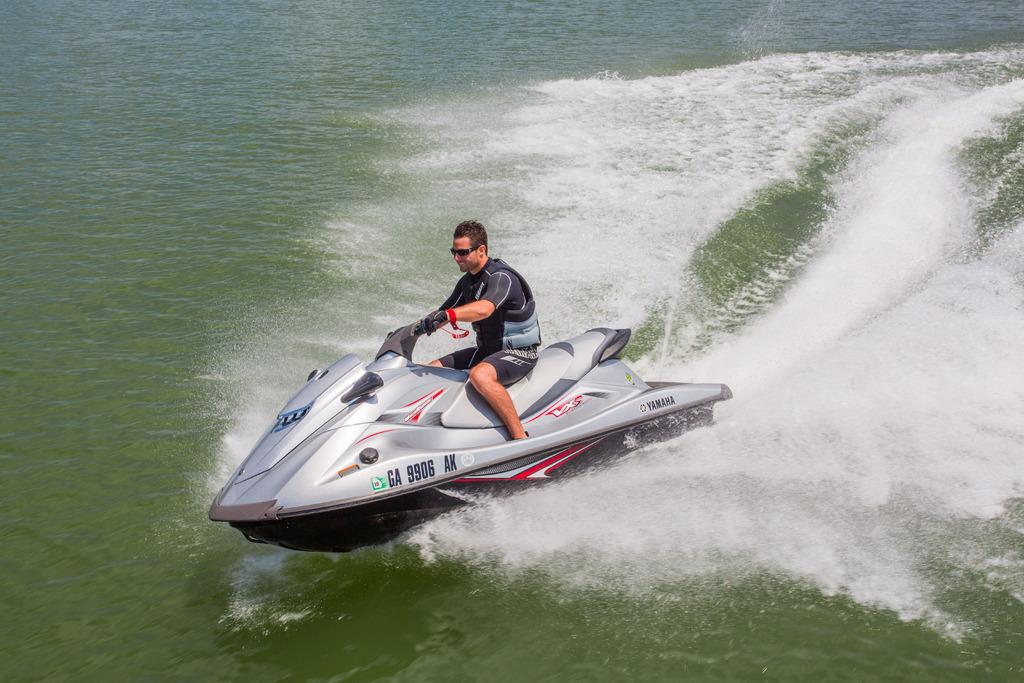Who is present in the image? There is a man in the image. What is the man doing in the image? The man is on a speedboat in the image. What type of environment is visible in the image? There is water visible in the image. What type of medical advice is the doctor giving to the man in the image? There is no doctor present in the image, so no medical advice can be given. 